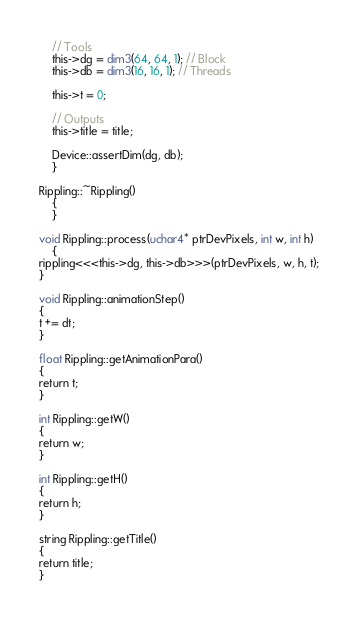<code> <loc_0><loc_0><loc_500><loc_500><_Cuda_>
    // Tools
    this->dg = dim3(64, 64, 1); // Block
    this->db = dim3(16, 16, 1); // Threads

    this->t = 0;
    
    // Outputs
    this->title = title;

    Device::assertDim(dg, db);
    }

Rippling::~Rippling()
    {
    }

void Rippling::process(uchar4* ptrDevPixels, int w, int h)
    {
rippling<<<this->dg, this->db>>>(ptrDevPixels, w, h, t);
}

void Rippling::animationStep()
{
t += dt;
}

float Rippling::getAnimationPara()
{
return t;
}

int Rippling::getW()
{
return w;
}

int Rippling::getH()
{
return h;
}

string Rippling::getTitle()
{
return title;
}
</code> 